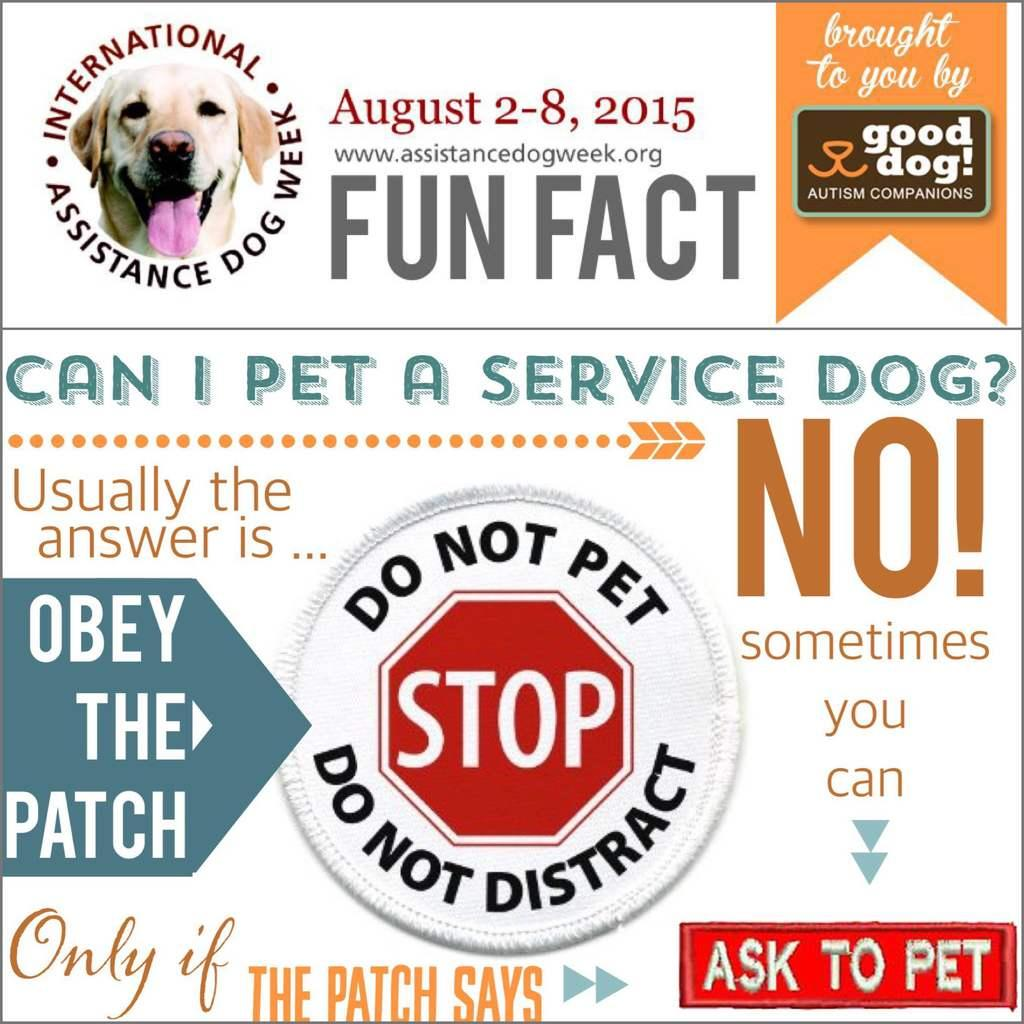What is present on the poster in the image? The poster contains text and an image. Can you describe the image on the poster? Unfortunately, the specific image on the poster cannot be described with the information provided. What type of content is conveyed through the text on the poster? The content of the text on the poster cannot be determined with the information provided. Can you see a kite being flown by a squirrel in the image? No, there is no kite or squirrel present in the image. 